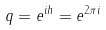Convert formula to latex. <formula><loc_0><loc_0><loc_500><loc_500>q = e ^ { i h } = e ^ { 2 \pi i }</formula> 